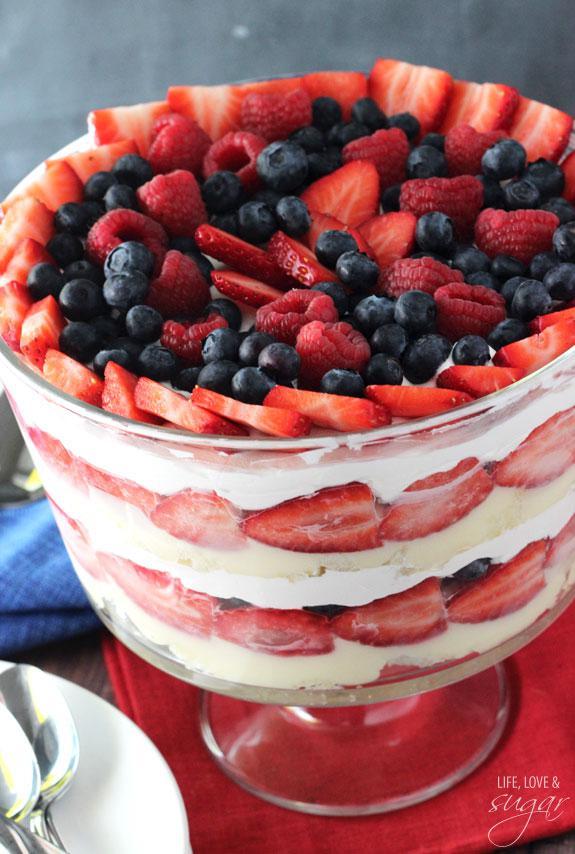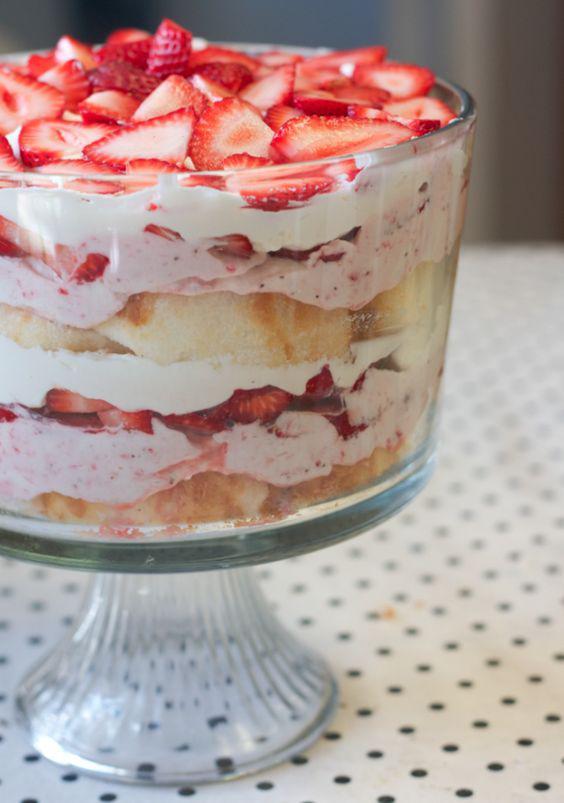The first image is the image on the left, the second image is the image on the right. Analyze the images presented: Is the assertion "The dessert is sitting on a folded red and white cloth in one image." valid? Answer yes or no. No. The first image is the image on the left, the second image is the image on the right. Considering the images on both sides, is "Two large fancy layered desserts are made with sliced strawberries." valid? Answer yes or no. Yes. 